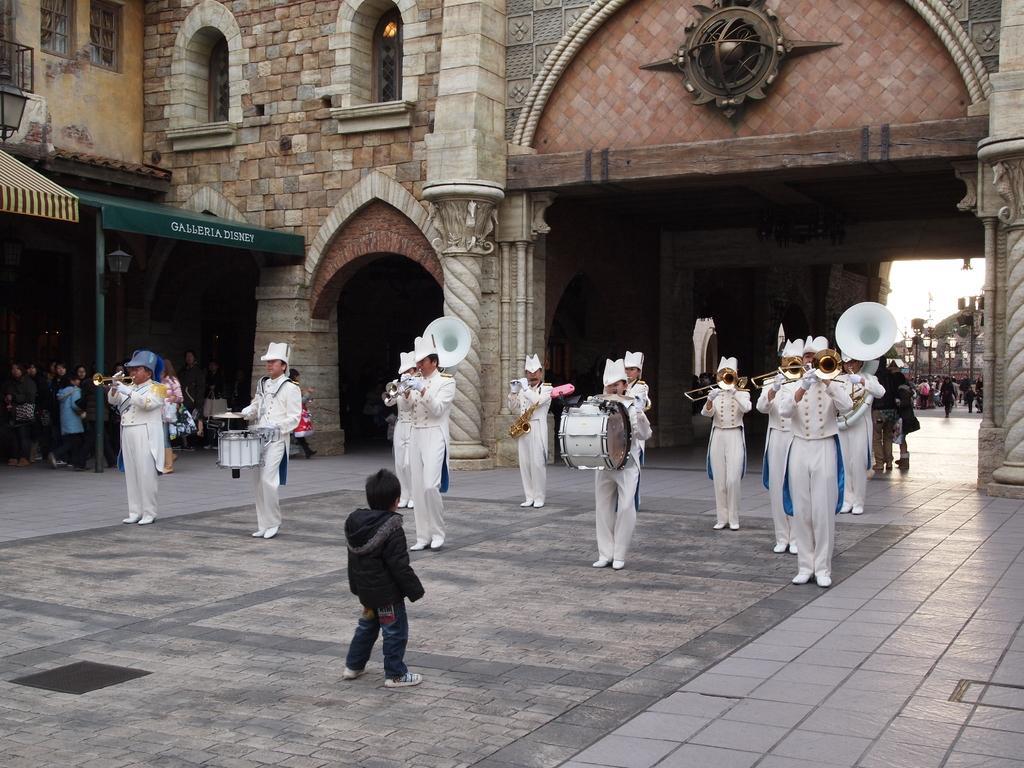Please provide a concise description of this image. In this image we can see some people standing holding some musical instruments. We can also see a child standing in front of them. On the backside we can see a building with windows, pillars and a roof. We can also see some street lamps and the sky. 